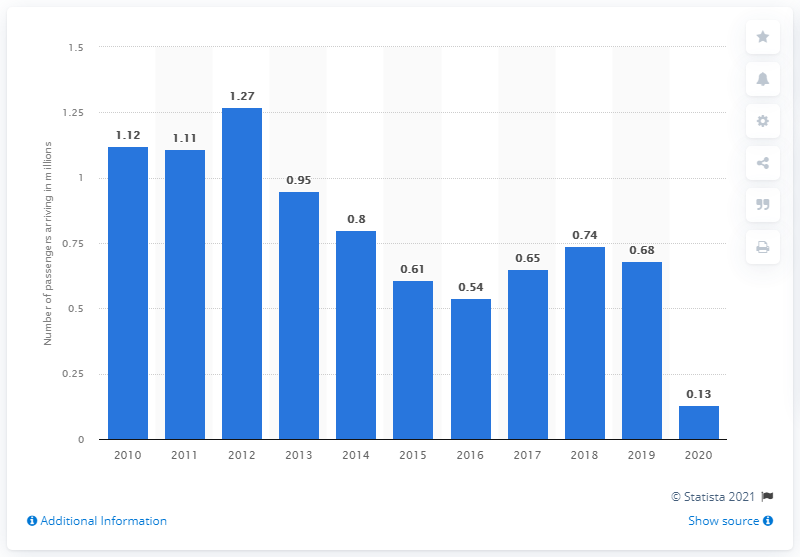Mention a couple of crucial points in this snapshot. In 2020, there were 0.13 million people in transit at Singaporean Changi Airport. In 2020, there were over 131 thousand people in transit at Singapore's Changi Airport. 